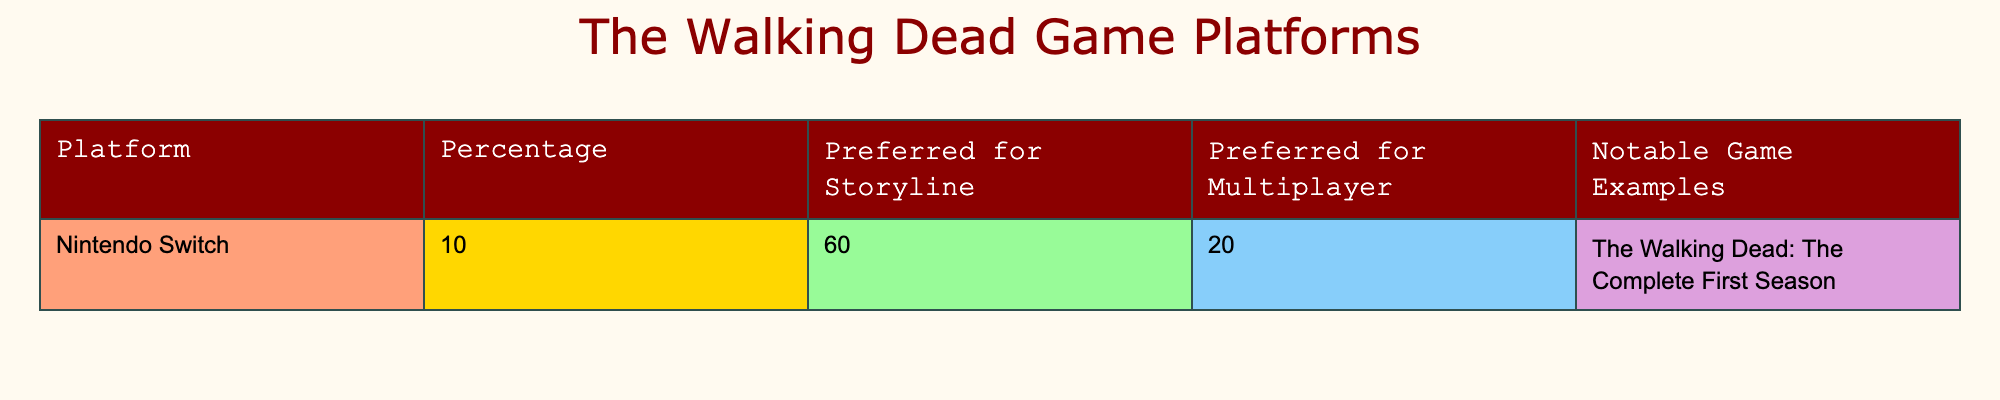What percentage of fans prefer the Nintendo Switch for multiplayer? From the table, the column under "Preferred for Multiplayer" shows the percentage for Nintendo Switch is 20%.
Answer: 20% What is the notable game example listed for Nintendo Switch? The table states that the notable game example for Nintendo Switch is "The Walking Dead: The Complete First Season."
Answer: The Walking Dead: The Complete First Season Is the Nintendo Switch more preferred for storyline or multiplayer? By comparing the "Preferred for Storyline" percentage (60%) with the "Preferred for Multiplayer" percentage (20%), it's clear that 60% is greater than 20%. Thus, the Nintendo Switch is more preferred for storyline.
Answer: Yes What is the difference between the percentages of storyline preference and multiplayer preference for the Nintendo Switch? The storyline preference percentage is 60% while the multiplayer preference percentage is 20%. To find the difference, 60% - 20% = 40%.
Answer: 40% Does the Nintendo Switch have more preference for multiplayer than the average value of 10%? The percentage for Nintendo Switch’s multiplayer preference is 20%. Since 20% is greater than the hypothetical average value of 10%, the answer is yes.
Answer: Yes What is the primary platform preference for storyline according to the data? The platform listed with the highest percentage for storyline preference is the Nintendo Switch at 60%.
Answer: Nintendo Switch How does the preference for storyline on Nintendo Switch compare to its multiplayer preference? The storyline preference is 60% while the multiplayer preference is 20%. The difference is significant, making storyline preference much higher in comparison.
Answer: Storyline preference is higher What percent of fans preferred Nintendo Switch for multiplayer versus storyline? From the "Preferred for Multiplayer," 20% preferred for multiplayer. For storyline, 60% preferred that. The comparison shows that 60% is significantly higher than 20%.
Answer: 20% for multiplayer, 60% for storyline 